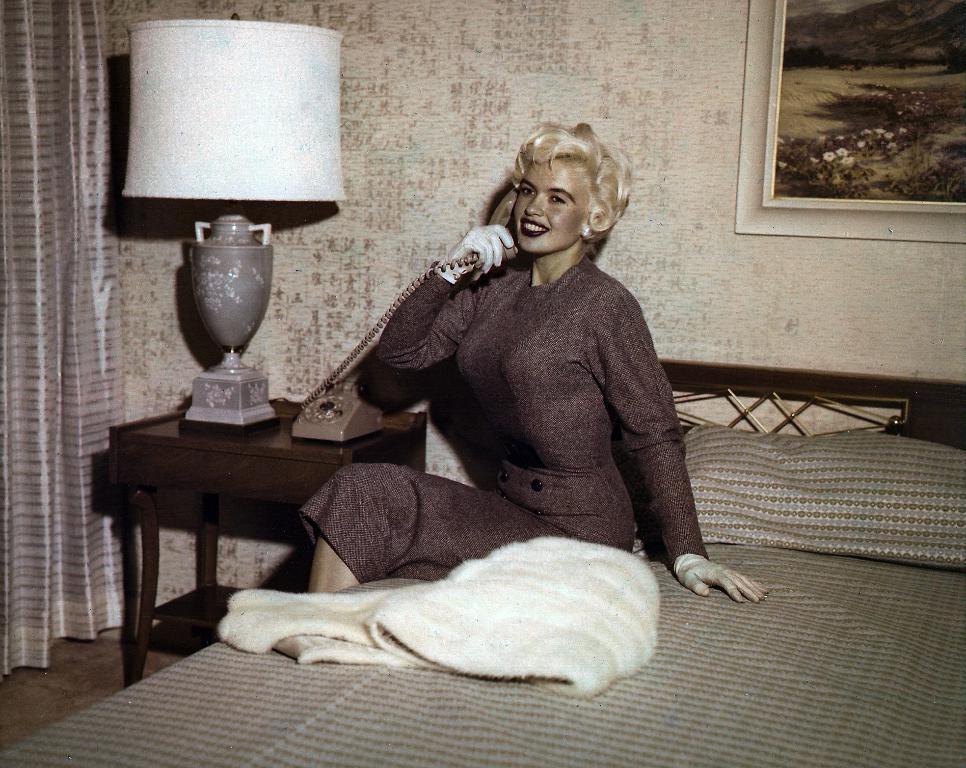Can you describe this image briefly? There is a lady sitting on bed, and talking in a telephone. There is a table near to her. On the table there is a table lamp and telephone. And on the bed there is pillow, bed sheet. On the background there is wall, photo frame and curtain. 